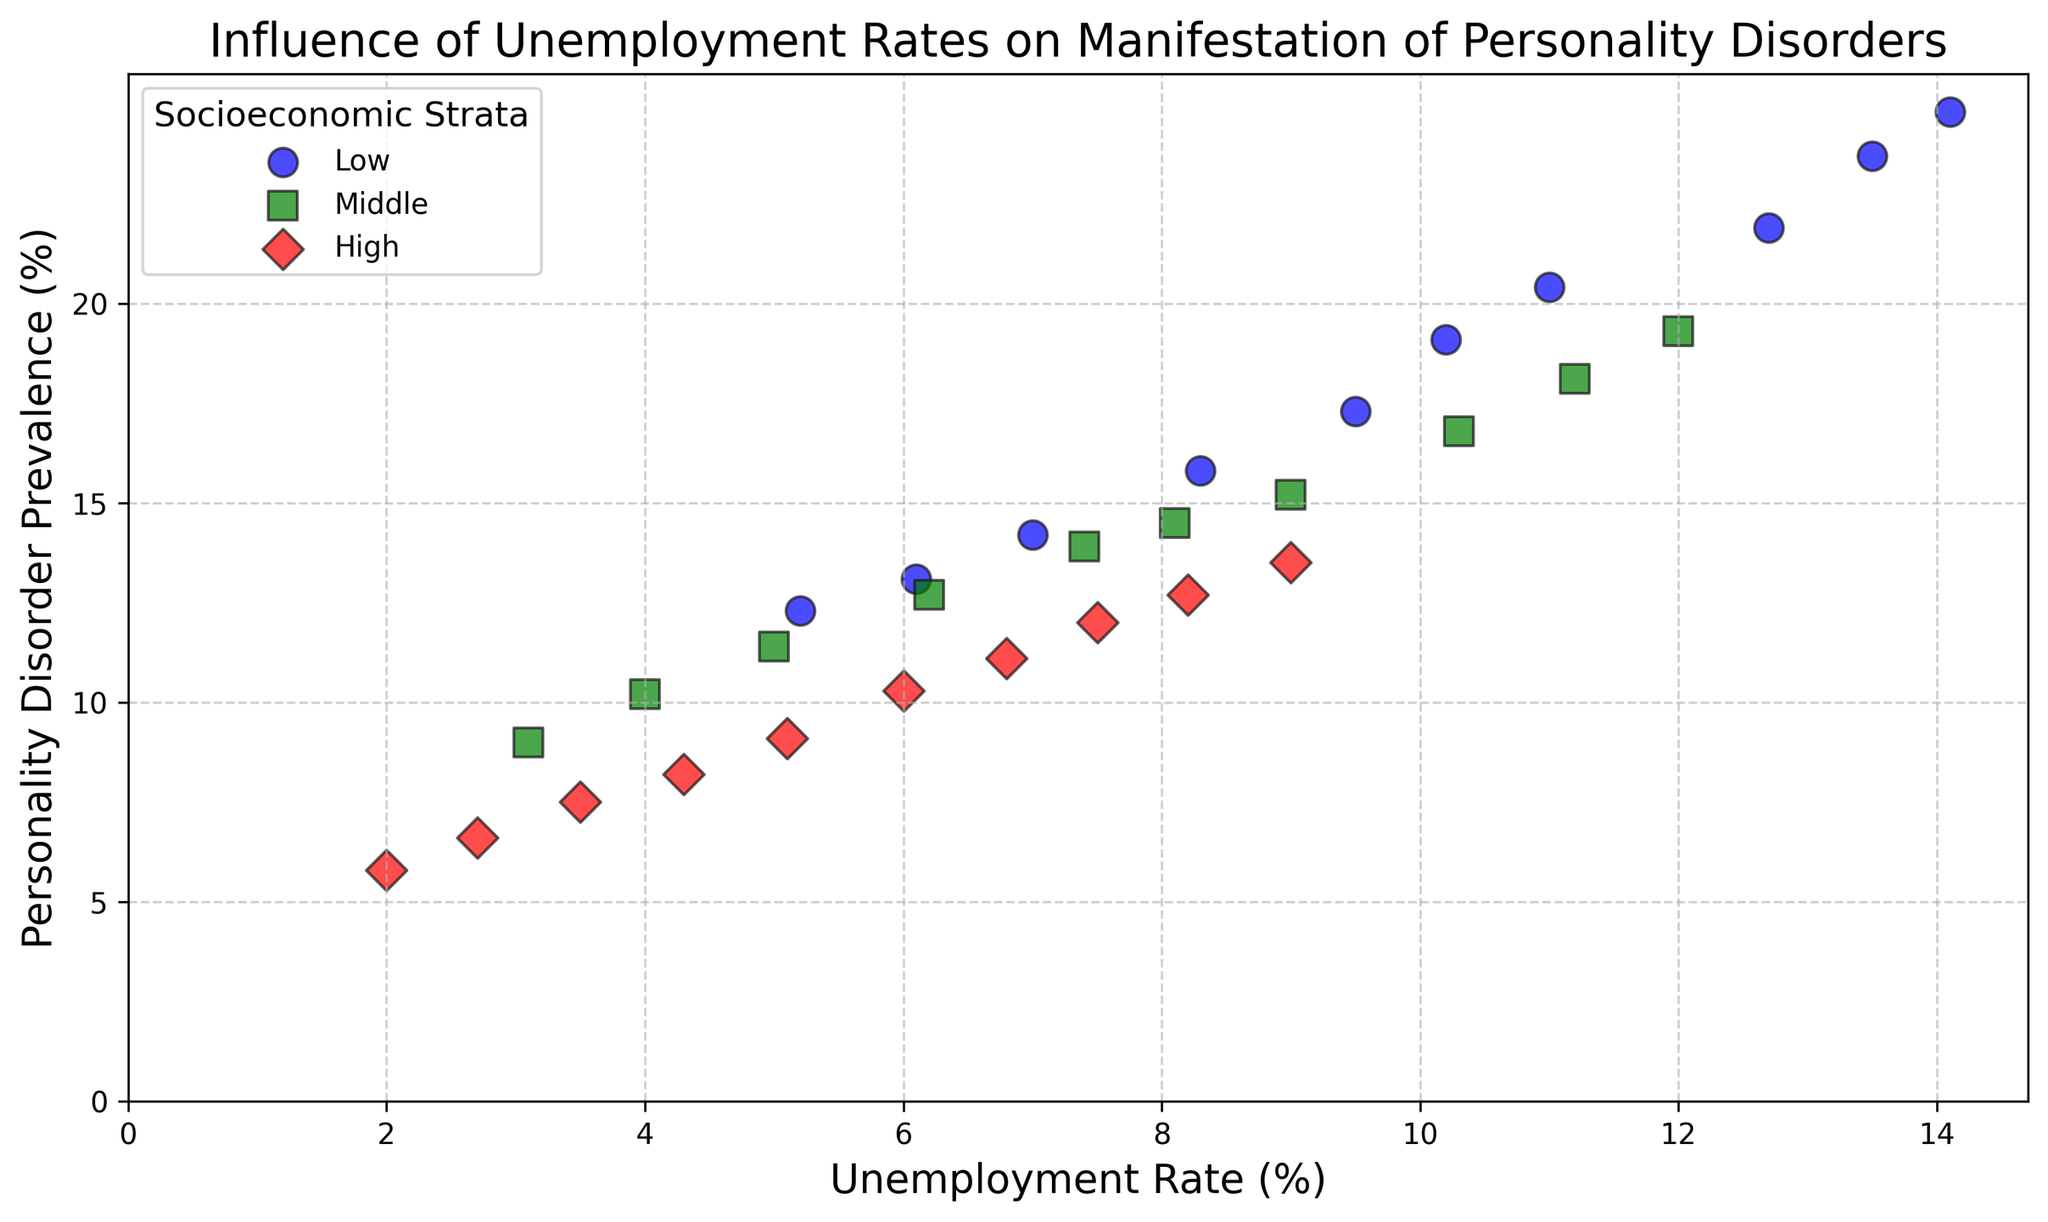What is the relationship between unemployment rate and personality disorder prevalence in the low socioeconomic stratum? In the figure, there is a clear positive trend where higher unemployment rates correspond to higher personality disorder prevalence within the low socioeconomic stratum. The scatter points for the low stratum, marked with blue circles, show an upward trajectory.
Answer: Positive correlation Which socioeconomic stratum has the highest overall prevalence of personality disorders? By visually inspecting the scatter points, the low socioeconomic stratum (blue circles) consistently shows the highest personality disorder prevalence at similar unemployment rates compared to the middle and high strata.
Answer: Low Comparing the low and high socioeconomic strata, how does the prevalence of personality disorders differ when the unemployment rate is 10%? At around a 10% unemployment rate, the low socioeconomic stratum has a personality disorder prevalence of about 19.1%, whereas the high socioeconomic stratum has a prevalence of about 10.3%, showing a significant difference.
Answer: Low: 19.1%, High: 10.3% What is the unemployment rate range shown in the figure for the middle socioeconomic stratum? The middle socioeconomic stratum (green squares) has unemployment rates ranging from 3.1% to 12%. This can be determined by looking at the x-axis values where green squares are plotted.
Answer: 3.1% to 12% How does the personality disorder prevalence in the middle socioeconomic stratum change as the unemployment rate increases from 4% to 10%? When the unemployment rate in the middle socioeconomic stratum increases from 4% to 10%, the personality disorder prevalence increases from 10.2% to 16.8%, indicating a clear upward trend.
Answer: Increases from 10.2% to 16.8% Which socioeconomic stratum shows the least variation in personality disorder prevalence? Visually assessing the spread of the scatter points, the high socioeconomic stratum (red diamonds) shows the least vertical spread in personality disorder prevalence, suggesting the least variation.
Answer: High At what unemployment rate do the middle and high socioeconomic strata have similar personality disorder prevalences, and what is the prevalence at that rate? At an unemployment rate of approximately 7.5%, the middle (green squares) and high (red diamonds) socioeconomic strata both have similar personality disorder prevalences of around 12-12.7%.
Answer: 7.5%, prevalence around 12-12.7% How does the pattern of personality disorder prevalence differ between the middle and low socioeconomic strata as the unemployment rate crosses 10%? As the unemployment rate crosses 10%, the middle socioeconomic stratum (green squares) shows a slower increase in personality disorder prevalence compared to the low stratum (blue circles), which shows a sharper rise. The low stratum has a rapid increase in prevalence beyond 10%.
Answer: Low stratum shows sharper rise How many socioeconomic strata display a personality disorder prevalence greater than 20%? By visually locating scatter points above the 20% mark on the y-axis, only the low socioeconomic stratum (blue circles) reaches a prevalence greater than 20%.
Answer: One What is the personality disorder prevalence at the lowest unemployment rate for each socioeconomic stratum in the figure? For the low socioeconomic stratum, at 5.2% unemployment, the prevalence is 12.3%. For the middle stratum, at 3.1% unemployment, the prevalence is 9%. For the high stratum, at 2% unemployment, the prevalence is 5.8%.
Answer: Low: 12.3%, Middle: 9%, High: 5.8% 